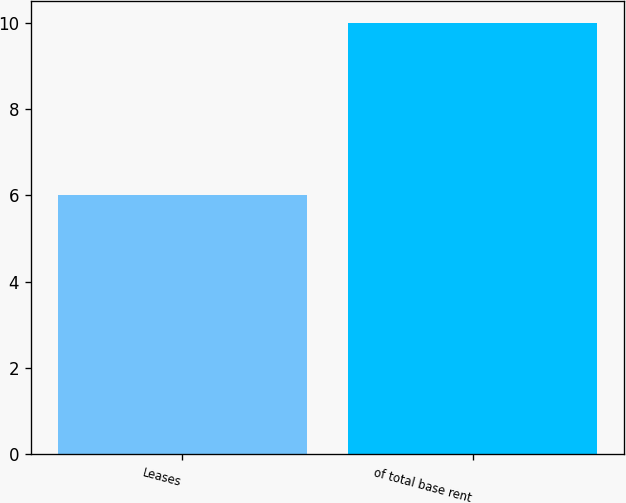Convert chart. <chart><loc_0><loc_0><loc_500><loc_500><bar_chart><fcel>Leases<fcel>of total base rent<nl><fcel>6<fcel>10<nl></chart> 